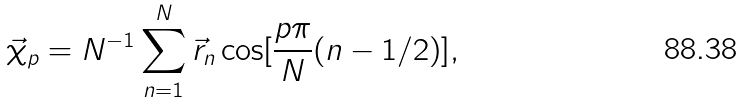Convert formula to latex. <formula><loc_0><loc_0><loc_500><loc_500>\vec { \chi } _ { p } = N ^ { - 1 } \sum _ { n = 1 } ^ { N } \vec { r } _ { n } \cos [ \frac { p \pi } { N } ( n - 1 / 2 ) ] ,</formula> 